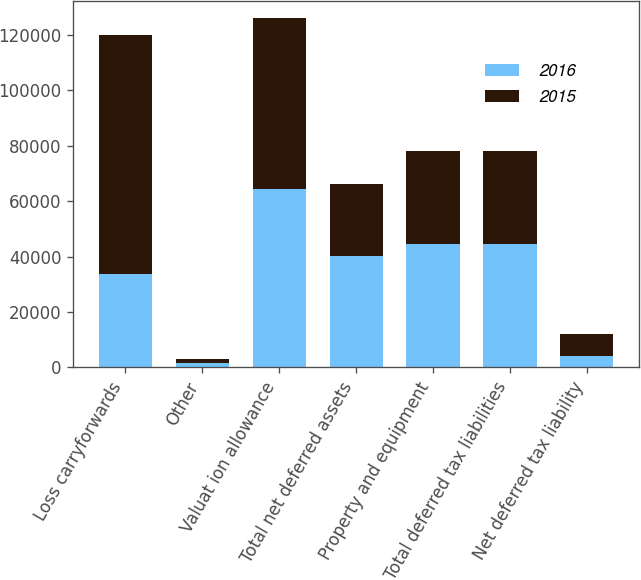Convert chart. <chart><loc_0><loc_0><loc_500><loc_500><stacked_bar_chart><ecel><fcel>Loss carryforwards<fcel>Other<fcel>Valuat ion allowance<fcel>Total net deferred assets<fcel>Property and equipment<fcel>Total deferred tax liabilities<fcel>Net deferred tax liability<nl><fcel>2016<fcel>33862<fcel>1564<fcel>64573<fcel>40182<fcel>44398<fcel>44398<fcel>4216<nl><fcel>2015<fcel>85939<fcel>1460<fcel>61437<fcel>25962<fcel>33862<fcel>33862<fcel>7900<nl></chart> 